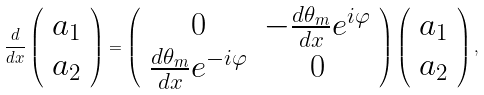Convert formula to latex. <formula><loc_0><loc_0><loc_500><loc_500>\frac { d } { d x } \left ( \begin{array} { c } a _ { 1 } \\ a _ { 2 } \end{array} \right ) = \left ( \begin{array} { c c } 0 & - \frac { d \theta _ { m } } { d x } e ^ { i \varphi } \\ \frac { d \theta _ { m } } { d x } e ^ { - i \varphi } & 0 \end{array} \right ) \left ( \begin{array} { c } a _ { 1 } \\ a _ { 2 } \end{array} \right ) ,</formula> 